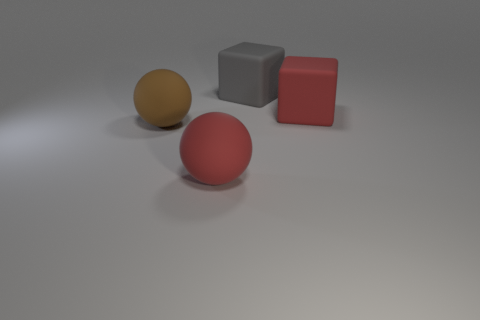Add 1 big brown matte things. How many objects exist? 5 Subtract all brown spheres. Subtract all big rubber balls. How many objects are left? 1 Add 2 big rubber cubes. How many big rubber cubes are left? 4 Add 3 big matte cubes. How many big matte cubes exist? 5 Subtract 1 brown spheres. How many objects are left? 3 